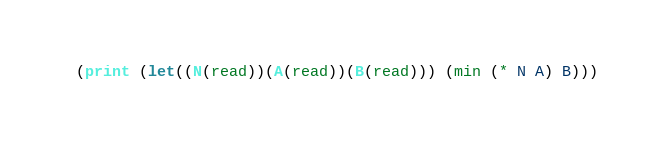<code> <loc_0><loc_0><loc_500><loc_500><_Scheme_>(print (let((N(read))(A(read))(B(read))) (min (* N A) B)))</code> 